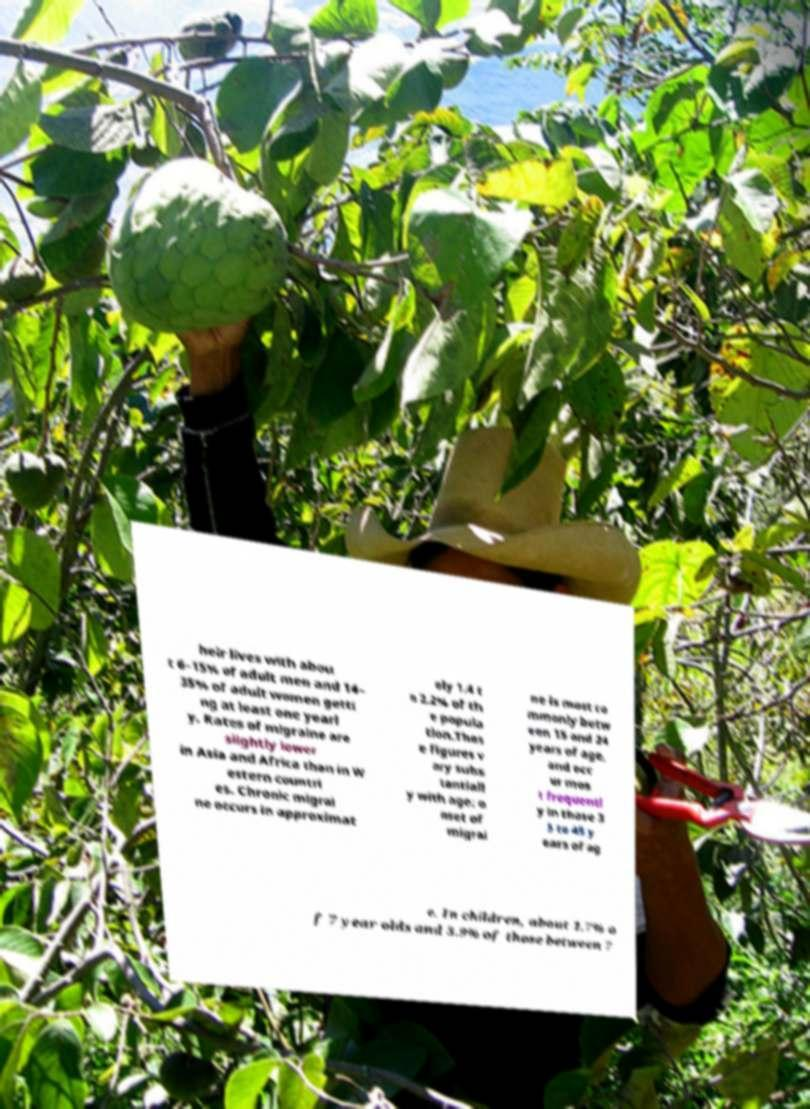Can you accurately transcribe the text from the provided image for me? heir lives with abou t 6–15% of adult men and 14– 35% of adult women getti ng at least one yearl y. Rates of migraine are slightly lower in Asia and Africa than in W estern countri es. Chronic migrai ne occurs in approximat ely 1.4 t o 2.2% of th e popula tion.Thes e figures v ary subs tantiall y with age: o nset of migrai ne is most co mmonly betw een 15 and 24 years of age, and occ ur mos t frequentl y in those 3 5 to 45 y ears of ag e. In children, about 1.7% o f 7 year olds and 3.9% of those between 7 